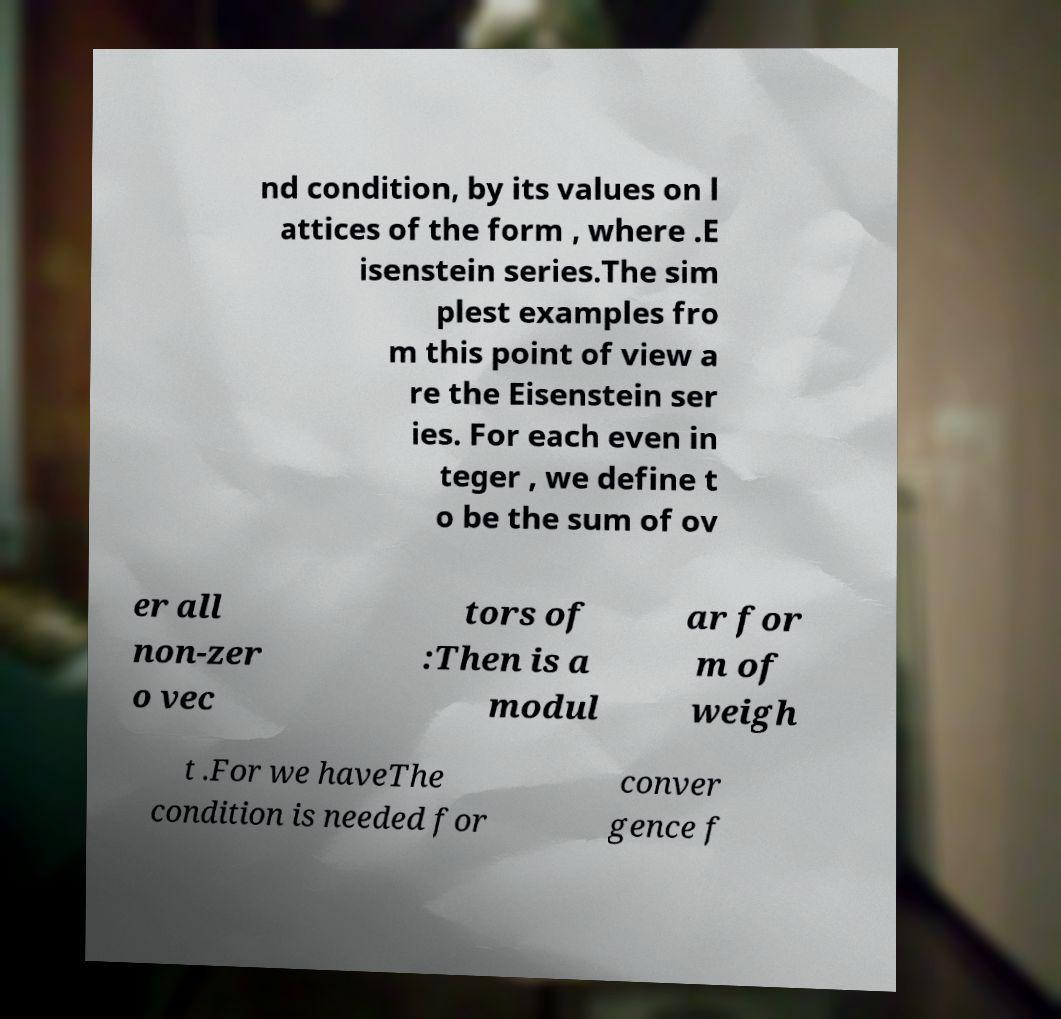Please identify and transcribe the text found in this image. nd condition, by its values on l attices of the form , where .E isenstein series.The sim plest examples fro m this point of view a re the Eisenstein ser ies. For each even in teger , we define t o be the sum of ov er all non-zer o vec tors of :Then is a modul ar for m of weigh t .For we haveThe condition is needed for conver gence f 